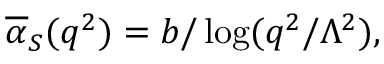<formula> <loc_0><loc_0><loc_500><loc_500>\overline { \alpha } _ { S } ( q ^ { 2 } ) = b / \log ( q ^ { 2 } / \Lambda ^ { 2 } ) ,</formula> 